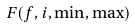<formula> <loc_0><loc_0><loc_500><loc_500>F ( f , i , \min , \max )</formula> 